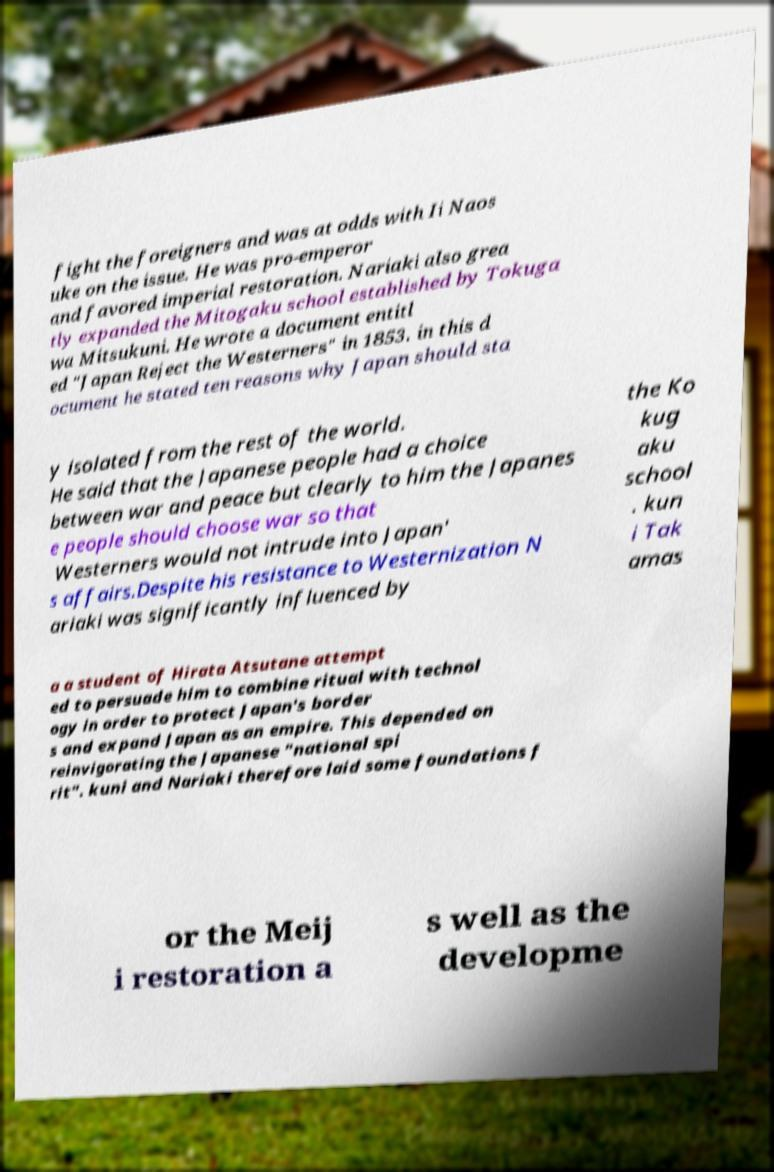Please read and relay the text visible in this image. What does it say? fight the foreigners and was at odds with Ii Naos uke on the issue. He was pro-emperor and favored imperial restoration. Nariaki also grea tly expanded the Mitogaku school established by Tokuga wa Mitsukuni. He wrote a document entitl ed "Japan Reject the Westerners" in 1853. in this d ocument he stated ten reasons why Japan should sta y isolated from the rest of the world. He said that the Japanese people had a choice between war and peace but clearly to him the Japanes e people should choose war so that Westerners would not intrude into Japan' s affairs.Despite his resistance to Westernization N ariaki was significantly influenced by the Ko kug aku school . kun i Tak amas a a student of Hirata Atsutane attempt ed to persuade him to combine ritual with technol ogy in order to protect Japan's border s and expand Japan as an empire. This depended on reinvigorating the Japanese "national spi rit". kuni and Nariaki therefore laid some foundations f or the Meij i restoration a s well as the developme 